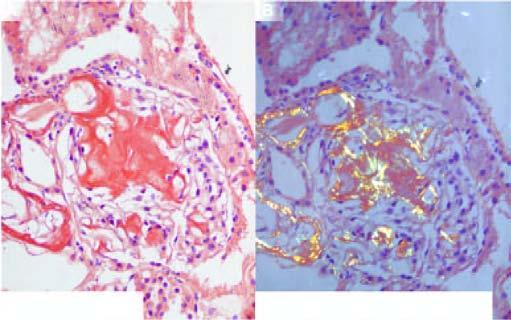do the congophilic areas show apple-green birefringence?
Answer the question using a single word or phrase. Yes 